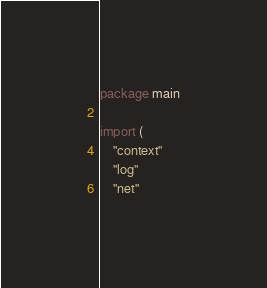Convert code to text. <code><loc_0><loc_0><loc_500><loc_500><_Go_>package main

import (
	"context"
	"log"
	"net"
</code> 